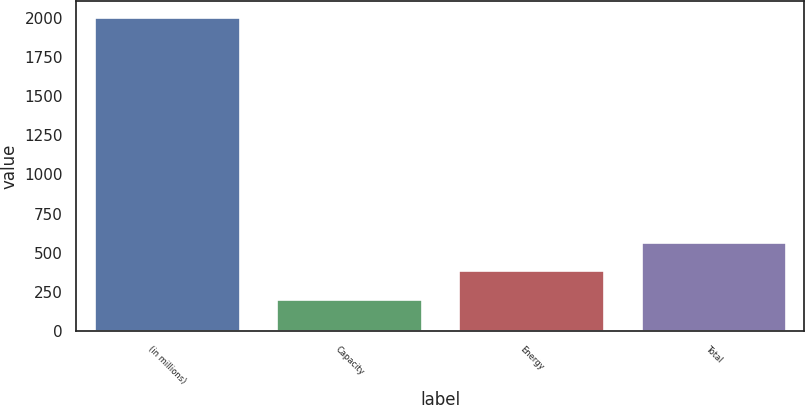<chart> <loc_0><loc_0><loc_500><loc_500><bar_chart><fcel>(in millions)<fcel>Capacity<fcel>Energy<fcel>Total<nl><fcel>2006<fcel>208<fcel>387.8<fcel>567.6<nl></chart> 